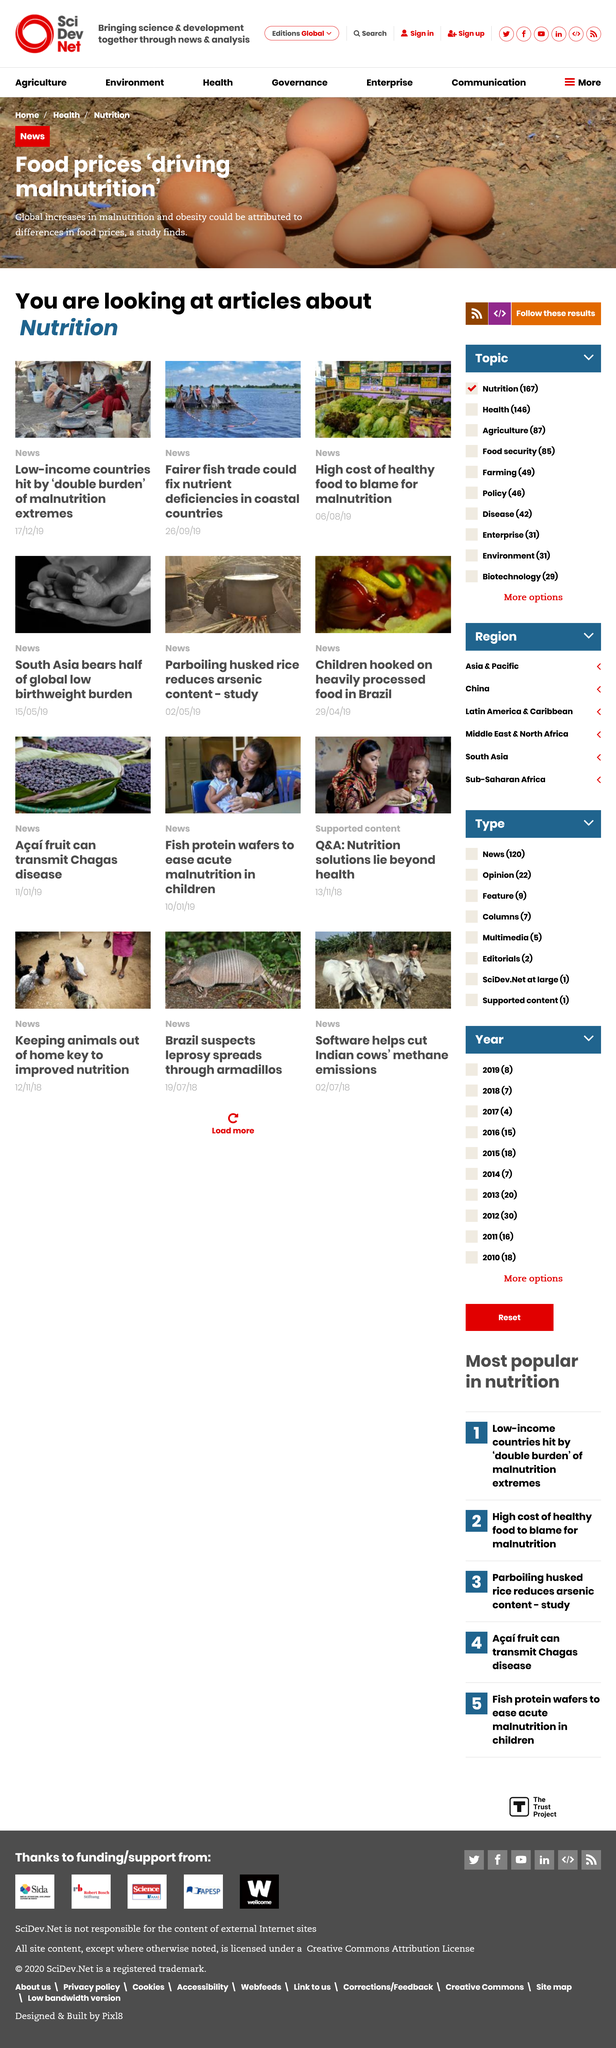Give some essential details in this illustration. A fairer fish trade could significantly address nutrient deficiencies in coastal countries. The topic of the articles is nutrition. The feature on the high cost of healthy food was published on August 6th, 2019. 